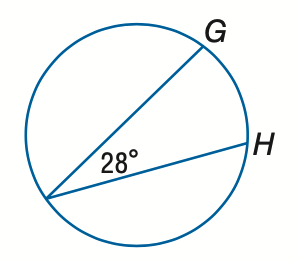Answer the mathemtical geometry problem and directly provide the correct option letter.
Question: Find the measure of m \widehat G H.
Choices: A: 28 B: 56 C: 84 D: 112 B 